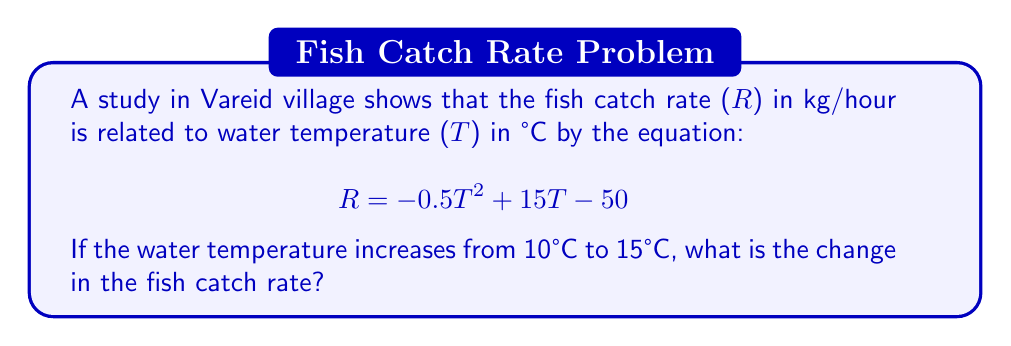Provide a solution to this math problem. Let's approach this step-by-step:

1) We need to calculate the catch rate at 10°C and 15°C, then find the difference.

2) For T = 10°C:
   $$R_{10} = -0.5(10)^2 + 15(10) - 50$$
   $$= -0.5(100) + 150 - 50$$
   $$= -50 + 150 - 50$$
   $$= 50 \text{ kg/hour}$$

3) For T = 15°C:
   $$R_{15} = -0.5(15)^2 + 15(15) - 50$$
   $$= -0.5(225) + 225 - 50$$
   $$= -112.5 + 225 - 50$$
   $$= 62.5 \text{ kg/hour}$$

4) The change in catch rate is the difference between these two values:
   $$\Delta R = R_{15} - R_{10}$$
   $$= 62.5 - 50$$
   $$= 12.5 \text{ kg/hour}$$

Therefore, the fish catch rate increases by 12.5 kg/hour when the water temperature rises from 10°C to 15°C.
Answer: 12.5 kg/hour 